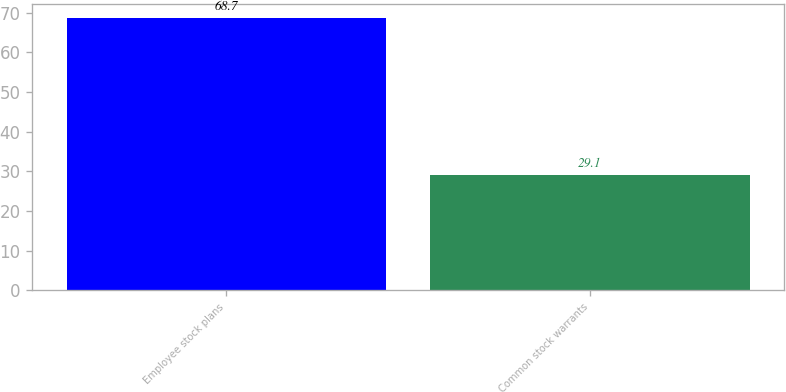Convert chart. <chart><loc_0><loc_0><loc_500><loc_500><bar_chart><fcel>Employee stock plans<fcel>Common stock warrants<nl><fcel>68.7<fcel>29.1<nl></chart> 